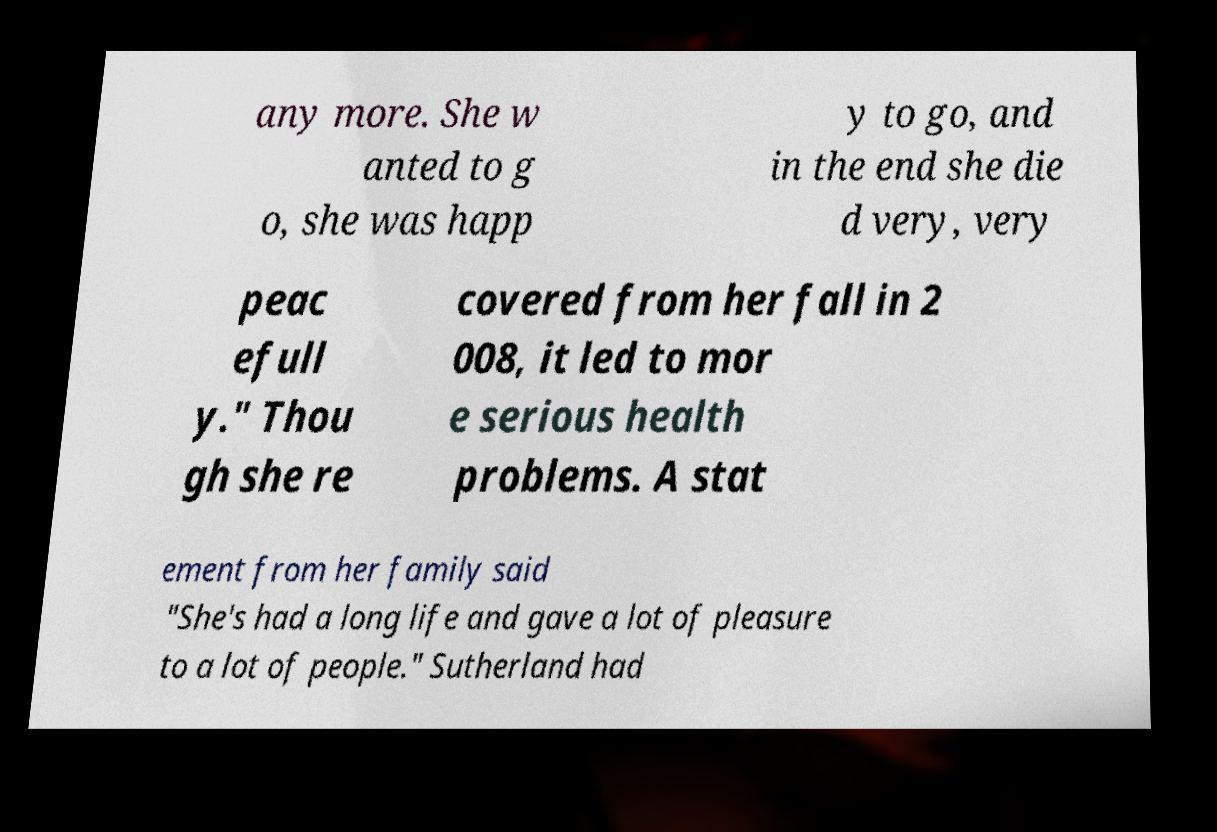Could you extract and type out the text from this image? any more. She w anted to g o, she was happ y to go, and in the end she die d very, very peac efull y." Thou gh she re covered from her fall in 2 008, it led to mor e serious health problems. A stat ement from her family said "She's had a long life and gave a lot of pleasure to a lot of people." Sutherland had 